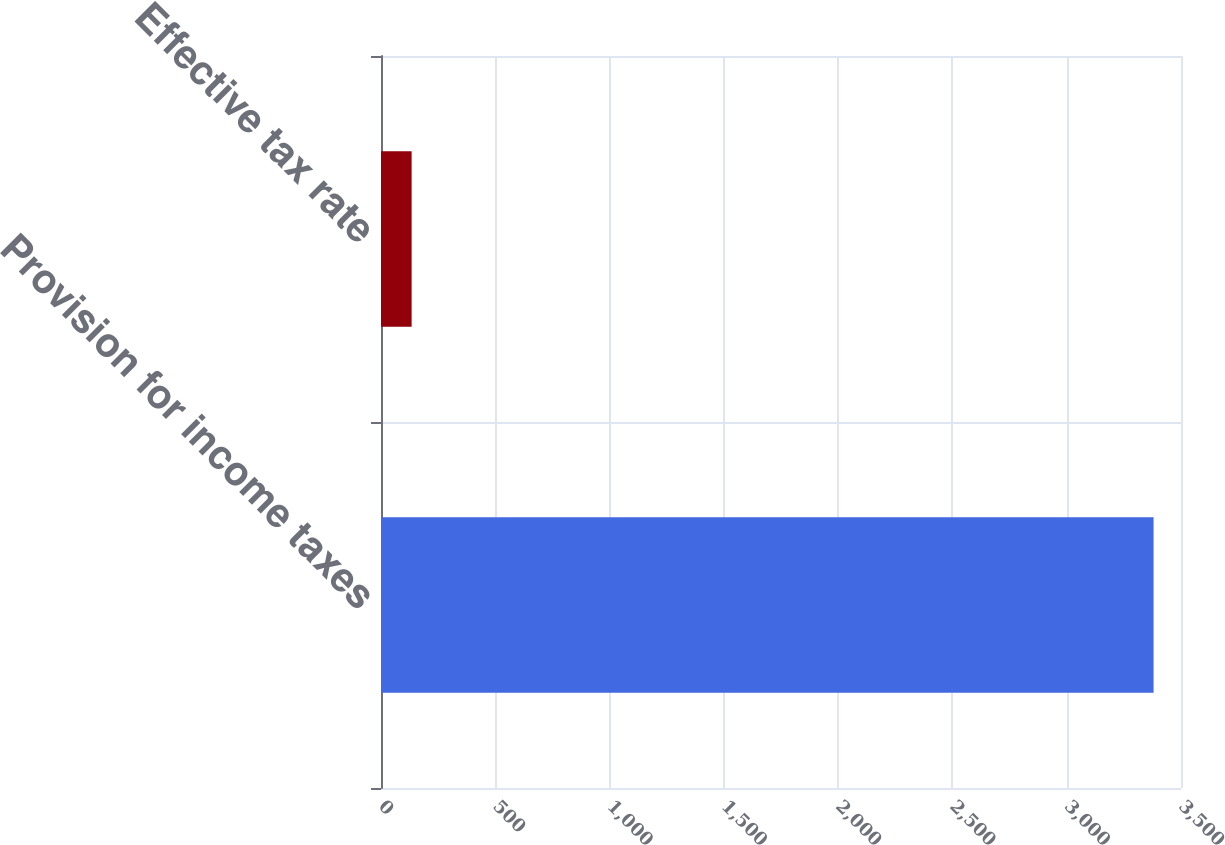Convert chart. <chart><loc_0><loc_0><loc_500><loc_500><bar_chart><fcel>Provision for income taxes<fcel>Effective tax rate<nl><fcel>3380<fcel>134<nl></chart> 